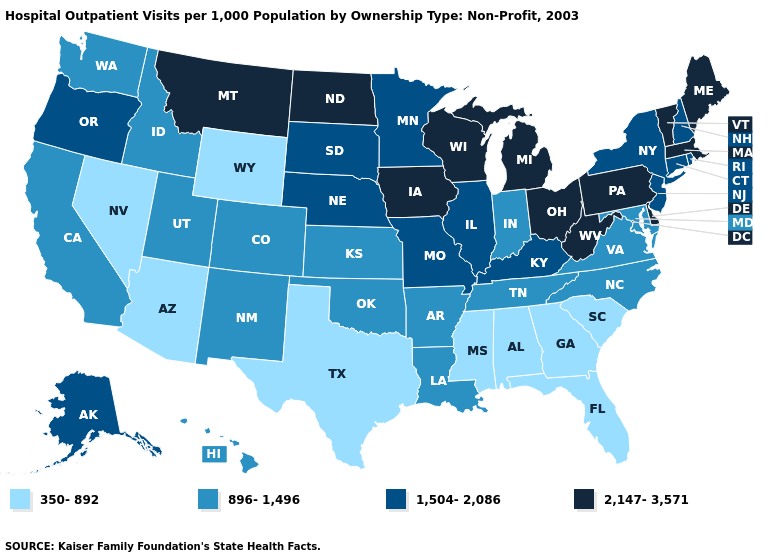What is the lowest value in states that border Nevada?
Write a very short answer. 350-892. Among the states that border Michigan , which have the lowest value?
Short answer required. Indiana. What is the value of Utah?
Give a very brief answer. 896-1,496. Does Alabama have the highest value in the USA?
Write a very short answer. No. Among the states that border New Jersey , does New York have the highest value?
Concise answer only. No. What is the value of Wyoming?
Short answer required. 350-892. What is the lowest value in the Northeast?
Answer briefly. 1,504-2,086. Does Rhode Island have a lower value than Vermont?
Concise answer only. Yes. Name the states that have a value in the range 896-1,496?
Write a very short answer. Arkansas, California, Colorado, Hawaii, Idaho, Indiana, Kansas, Louisiana, Maryland, New Mexico, North Carolina, Oklahoma, Tennessee, Utah, Virginia, Washington. Name the states that have a value in the range 896-1,496?
Concise answer only. Arkansas, California, Colorado, Hawaii, Idaho, Indiana, Kansas, Louisiana, Maryland, New Mexico, North Carolina, Oklahoma, Tennessee, Utah, Virginia, Washington. What is the lowest value in states that border Indiana?
Short answer required. 1,504-2,086. Name the states that have a value in the range 350-892?
Keep it brief. Alabama, Arizona, Florida, Georgia, Mississippi, Nevada, South Carolina, Texas, Wyoming. Name the states that have a value in the range 2,147-3,571?
Short answer required. Delaware, Iowa, Maine, Massachusetts, Michigan, Montana, North Dakota, Ohio, Pennsylvania, Vermont, West Virginia, Wisconsin. Among the states that border Alabama , which have the lowest value?
Give a very brief answer. Florida, Georgia, Mississippi. Among the states that border Utah , which have the highest value?
Give a very brief answer. Colorado, Idaho, New Mexico. 